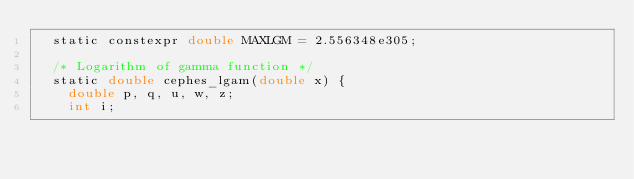Convert code to text. <code><loc_0><loc_0><loc_500><loc_500><_Cuda_>  static constexpr double MAXLGM = 2.556348e305;

  /* Logarithm of gamma function */
  static double cephes_lgam(double x) {
    double p, q, u, w, z;
    int i;
</code> 